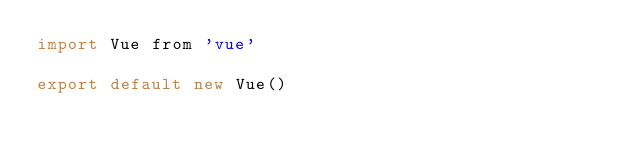Convert code to text. <code><loc_0><loc_0><loc_500><loc_500><_JavaScript_>import Vue from 'vue'

export default new Vue()
</code> 